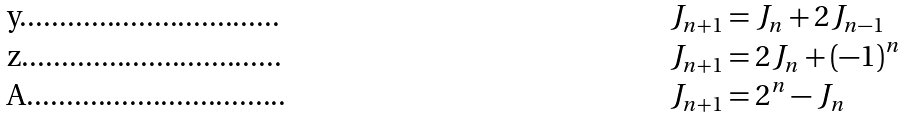<formula> <loc_0><loc_0><loc_500><loc_500>J _ { n + 1 } & = J _ { n } + 2 J _ { n - 1 } \\ J _ { n + 1 } & = 2 J _ { n } + ( - 1 ) ^ { n } \\ J _ { n + 1 } & = 2 ^ { n } - J _ { n }</formula> 